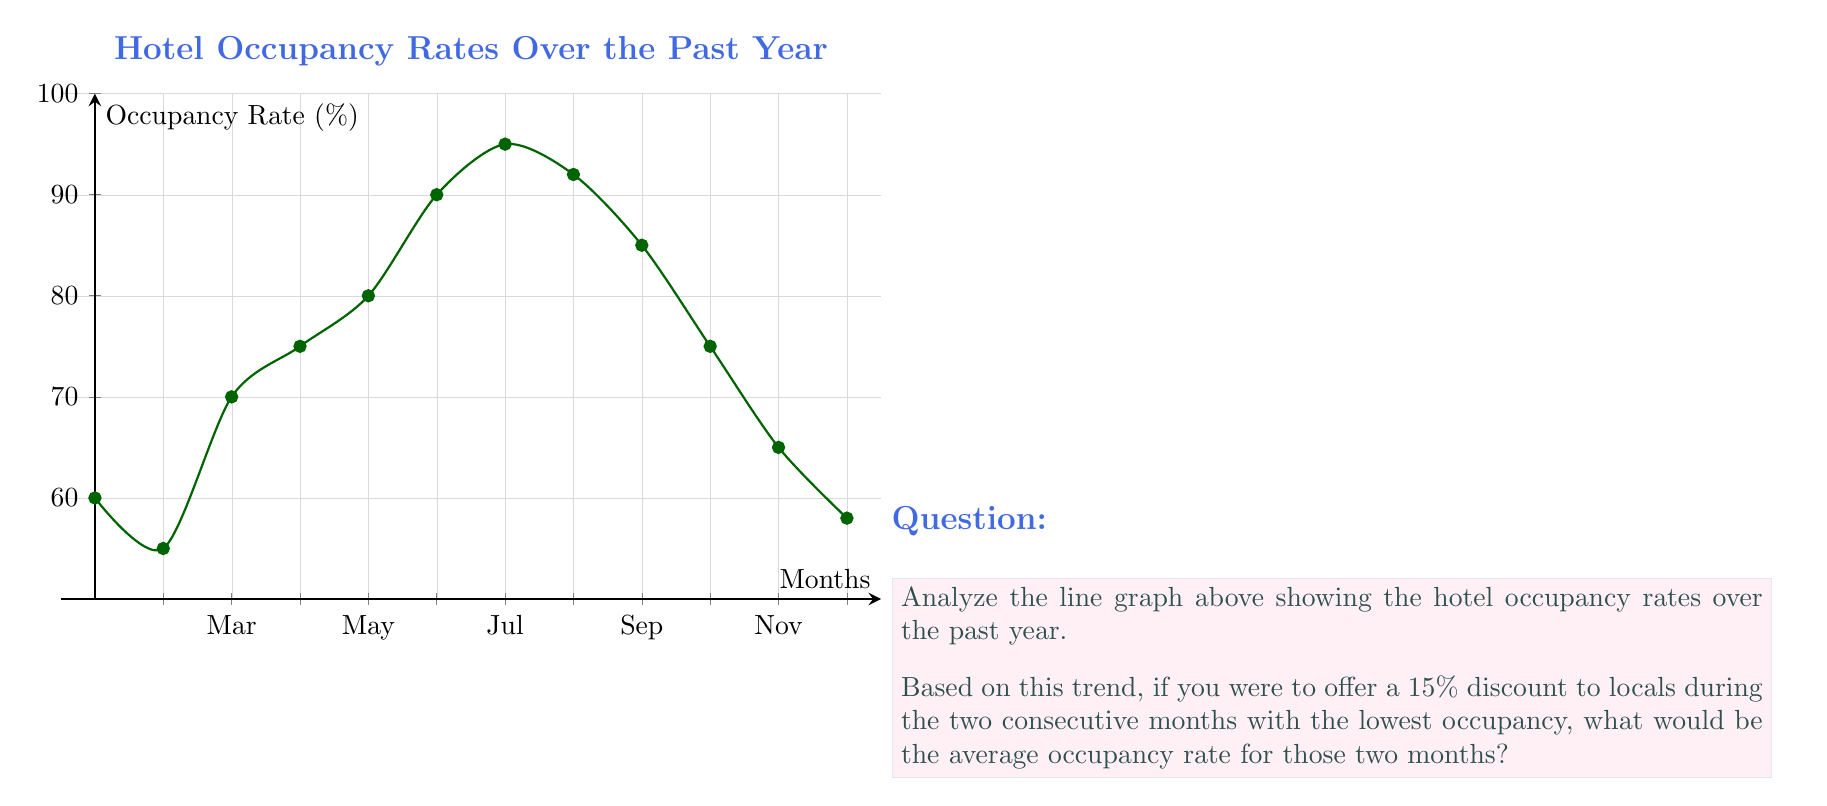Help me with this question. To solve this problem, we need to follow these steps:

1) Identify the two consecutive months with the lowest occupancy:
   Looking at the graph, we can see that the lowest point is in February (the 2nd month), and the next lowest is in January (the 1st month).

2) Determine the occupancy rates for these two months:
   January: 60%
   February: 55%

3) Calculate the average occupancy rate:
   $$ \text{Average} = \frac{\text{January rate} + \text{February rate}}{2} = \frac{60\% + 55\%}{2} = \frac{115\%}{2} = 57.5\% $$

4) Apply the 15% discount:
   A 15% discount would potentially increase occupancy. However, the question asks for the current average occupancy rate of these two months, not the potential future rate after applying the discount.

Therefore, the average occupancy rate for the two consecutive months with the lowest occupancy is 57.5%.
Answer: 57.5% 